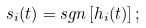Convert formula to latex. <formula><loc_0><loc_0><loc_500><loc_500>s _ { i } ( t ) = s g n \left [ h _ { i } ( t ) \right ] ;</formula> 